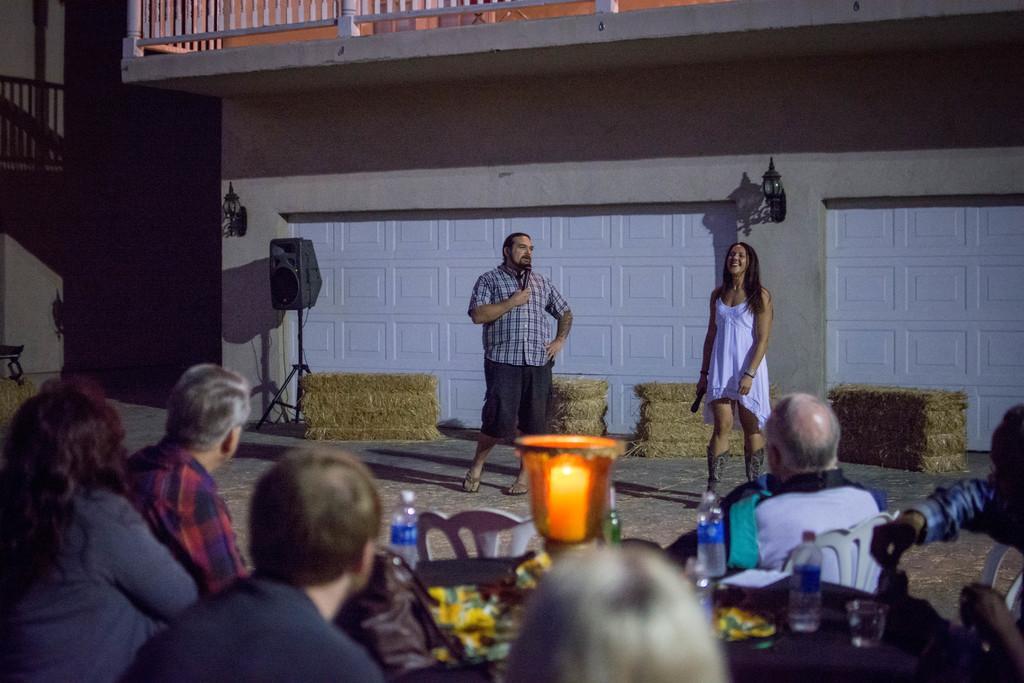Describe this image in one or two sentences. It is a party and there are group of people sitting around the table and there is a lamp in between the table and there are water bottles around the lamp and in the front a women and man are standing by holding a mic and behind these people there is a big speaker and behind the speaker there is a building. 